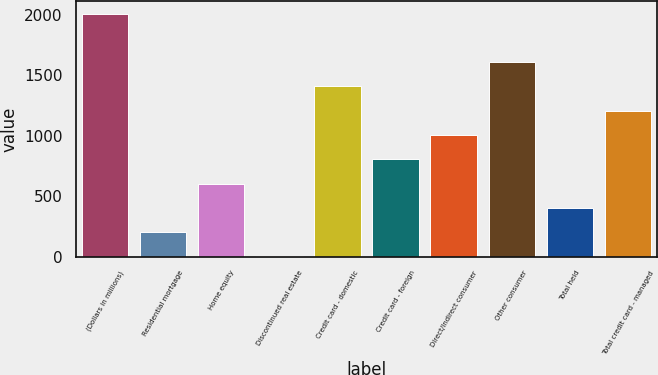Convert chart. <chart><loc_0><loc_0><loc_500><loc_500><bar_chart><fcel>(Dollars in millions)<fcel>Residential mortgage<fcel>Home equity<fcel>Discontinued real estate<fcel>Credit card - domestic<fcel>Credit card - foreign<fcel>Direct/Indirect consumer<fcel>Other consumer<fcel>Total held<fcel>Total credit card - managed<nl><fcel>2008<fcel>200.94<fcel>602.51<fcel>0.15<fcel>1405.64<fcel>803.29<fcel>1004.07<fcel>1606.43<fcel>401.73<fcel>1204.86<nl></chart> 